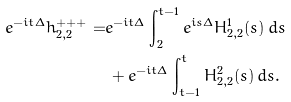<formula> <loc_0><loc_0><loc_500><loc_500>e ^ { - i t \Delta } h _ { 2 , 2 } ^ { + + + } = & e ^ { - i t \Delta } \int _ { 2 } ^ { t - 1 } e ^ { i s \Delta } H ^ { 1 } _ { 2 , 2 } ( s ) \, d s \\ & \, + e ^ { - i t \Delta } \int _ { t - 1 } ^ { t } H ^ { 2 } _ { 2 , 2 } ( s ) \, d s .</formula> 